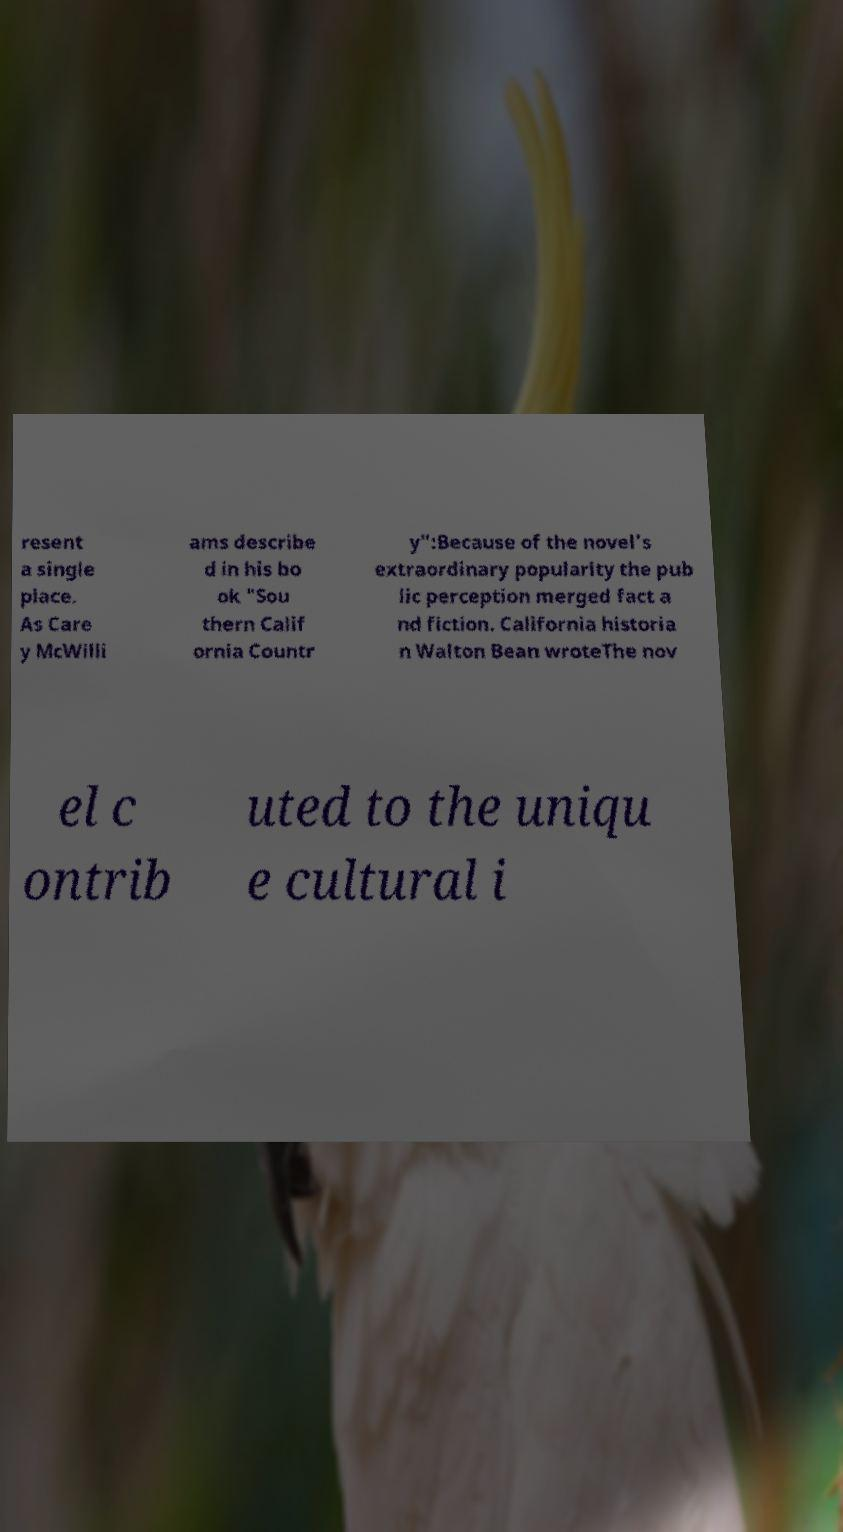Can you accurately transcribe the text from the provided image for me? resent a single place. As Care y McWilli ams describe d in his bo ok "Sou thern Calif ornia Countr y":Because of the novel's extraordinary popularity the pub lic perception merged fact a nd fiction. California historia n Walton Bean wroteThe nov el c ontrib uted to the uniqu e cultural i 